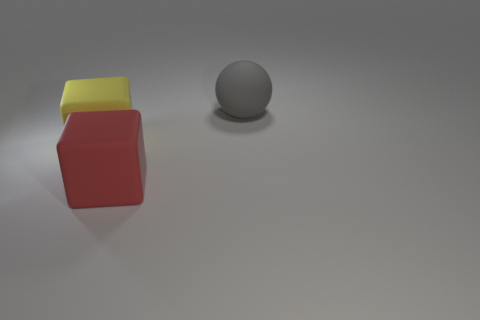Add 2 gray objects. How many objects exist? 5 Subtract all balls. How many objects are left? 2 Subtract 0 blue spheres. How many objects are left? 3 Subtract all matte balls. Subtract all rubber blocks. How many objects are left? 0 Add 3 big blocks. How many big blocks are left? 5 Add 1 big blue rubber spheres. How many big blue rubber spheres exist? 1 